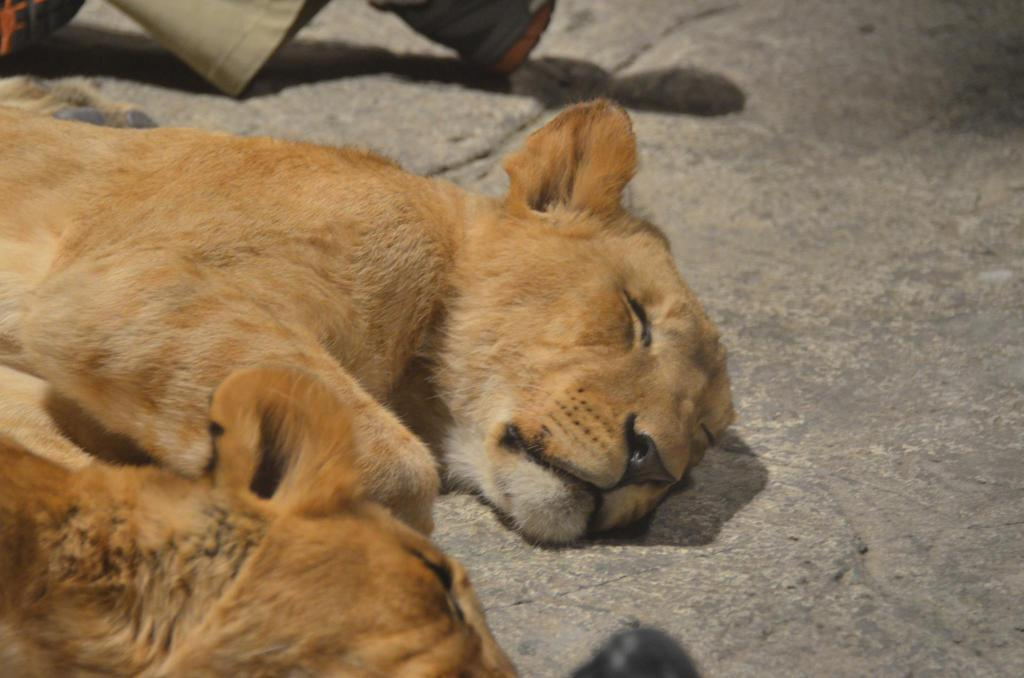How many cubs are in the image? There are two cubs in the image. What are the cubs doing in the image? The cubs are sleeping on the floor. What can be seen at the top of the image? There is a cloth visible at the top of the image, and footwears are also present there. What type of pie is being invented by the cubs in the image? There is no pie or invention activity present in the image; the cubs are sleeping on the floor. 